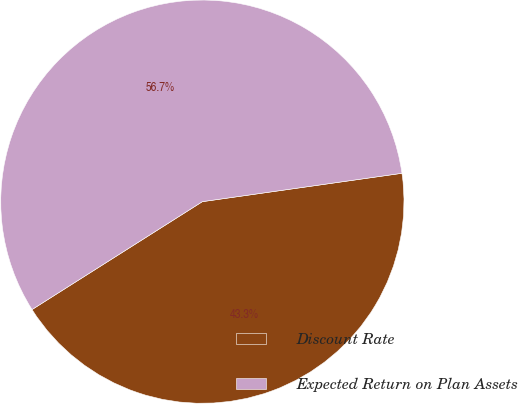Convert chart to OTSL. <chart><loc_0><loc_0><loc_500><loc_500><pie_chart><fcel>Discount Rate<fcel>Expected Return on Plan Assets<nl><fcel>43.26%<fcel>56.74%<nl></chart> 